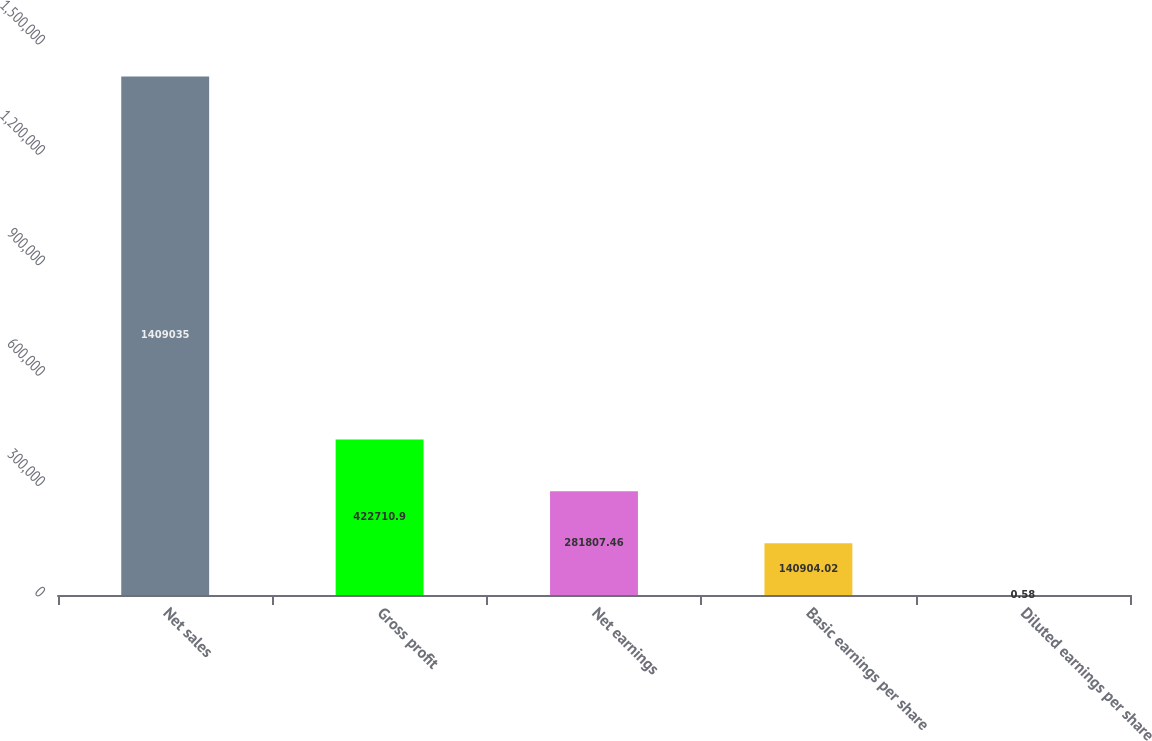<chart> <loc_0><loc_0><loc_500><loc_500><bar_chart><fcel>Net sales<fcel>Gross profit<fcel>Net earnings<fcel>Basic earnings per share<fcel>Diluted earnings per share<nl><fcel>1.40904e+06<fcel>422711<fcel>281807<fcel>140904<fcel>0.58<nl></chart> 